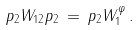Convert formula to latex. <formula><loc_0><loc_0><loc_500><loc_500>p _ { 2 } W _ { 1 2 } p _ { 2 } \, = \, p _ { 2 } W _ { 1 } ^ { \varphi } \, .</formula> 